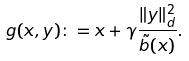Convert formula to latex. <formula><loc_0><loc_0><loc_500><loc_500>g ( x , y ) \colon = x + \gamma \frac { \| y \| _ { d } ^ { 2 } } { \tilde { b } ( x ) } .</formula> 